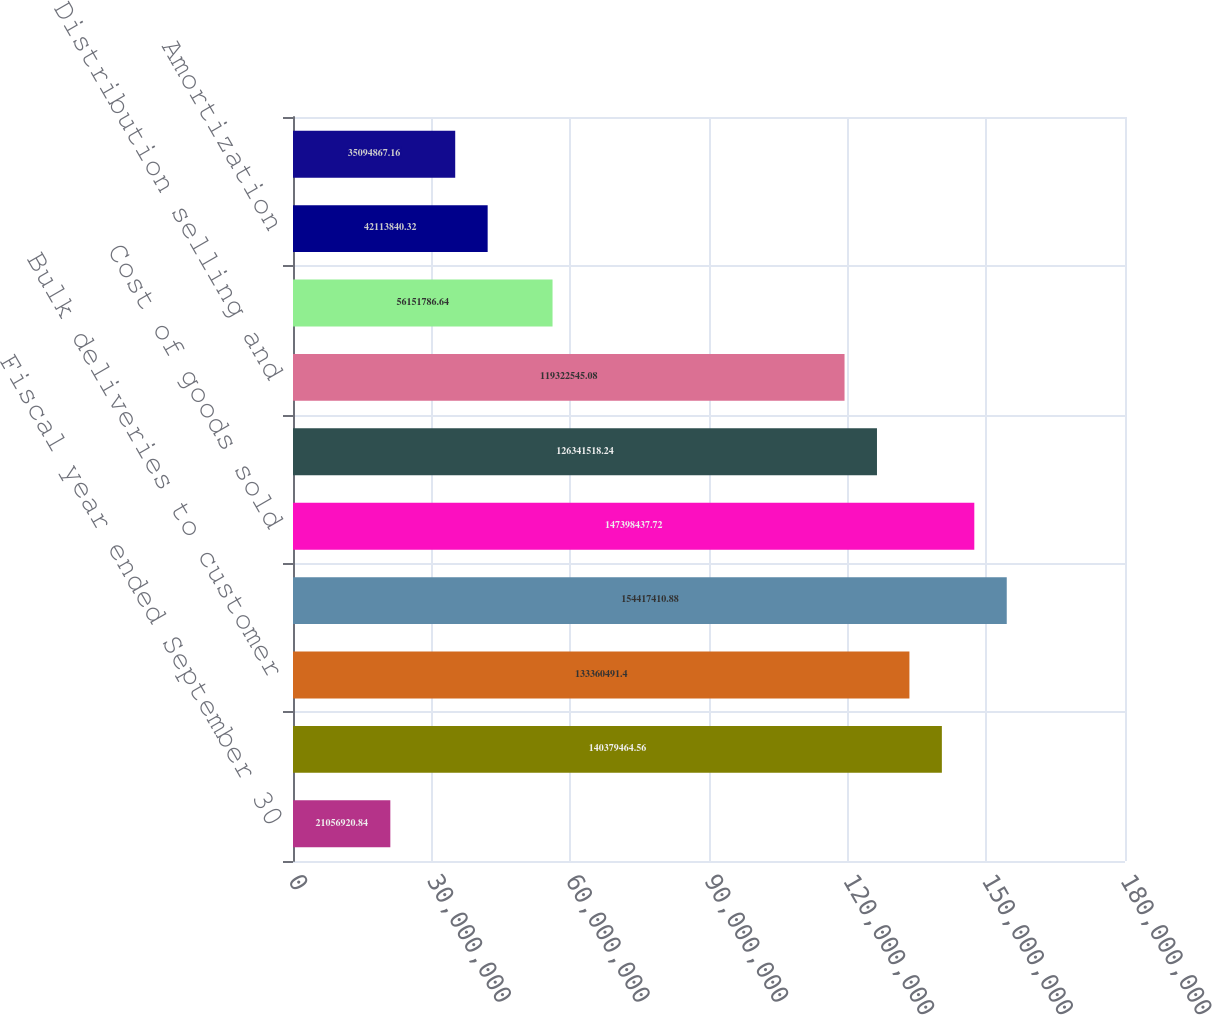Convert chart. <chart><loc_0><loc_0><loc_500><loc_500><bar_chart><fcel>Fiscal year ended September 30<fcel>Operating revenue<fcel>Bulk deliveries to customer<fcel>Total revenue<fcel>Cost of goods sold<fcel>Gross profit<fcel>Distribution selling and<fcel>Depreciation<fcel>Amortization<fcel>Facility consolidations<nl><fcel>2.10569e+07<fcel>1.40379e+08<fcel>1.3336e+08<fcel>1.54417e+08<fcel>1.47398e+08<fcel>1.26342e+08<fcel>1.19323e+08<fcel>5.61518e+07<fcel>4.21138e+07<fcel>3.50949e+07<nl></chart> 